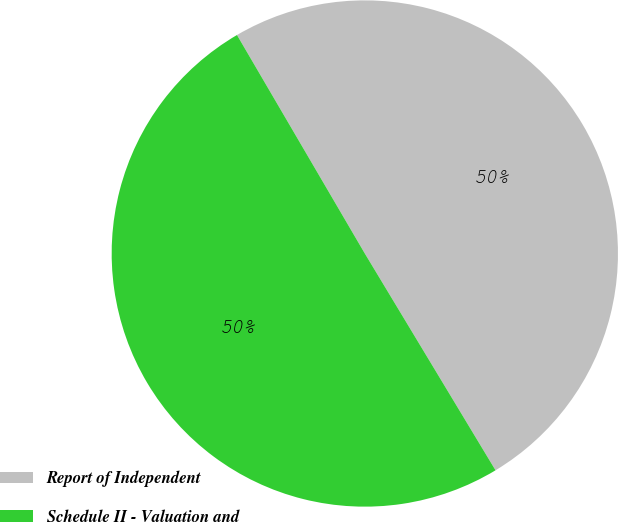Convert chart. <chart><loc_0><loc_0><loc_500><loc_500><pie_chart><fcel>Report of Independent<fcel>Schedule II - Valuation and<nl><fcel>49.79%<fcel>50.21%<nl></chart> 